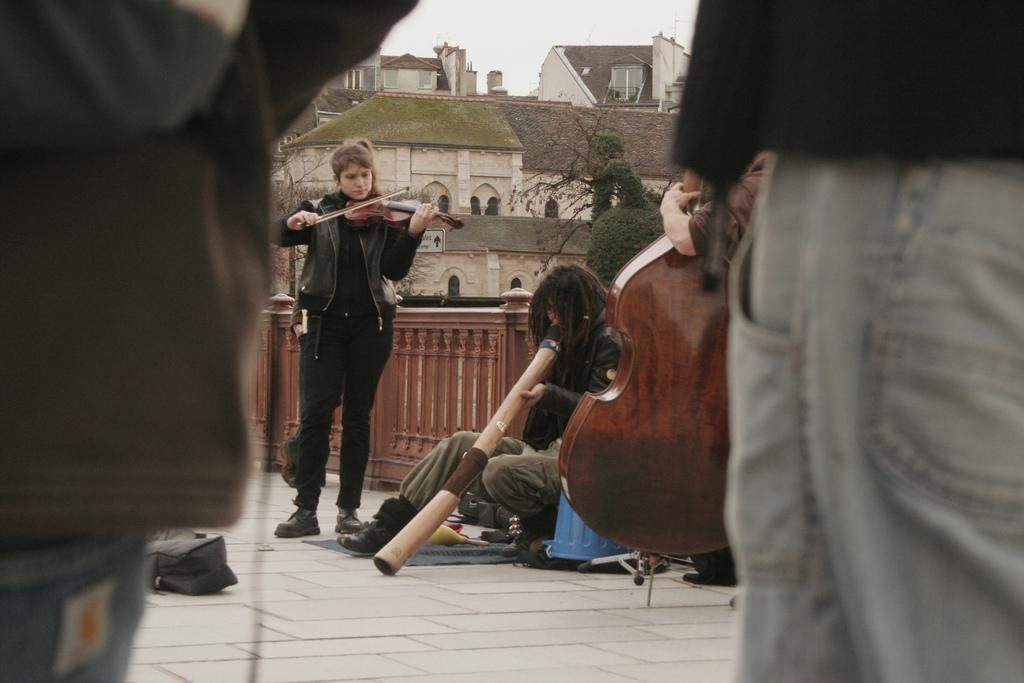What is the woman in the image doing? The woman is playing a violin in the image. Who else is present in the image? There is a man in the image. Where is the man located in the image? The man is sitting on the side of the road. What can be seen in the background of the image? There are houses, trees, and the sky visible in the background of the image. What type of toys can be seen in the image? There are no toys present in the image. Is there a pig visible in the image? No, there is no pig present in the image. 